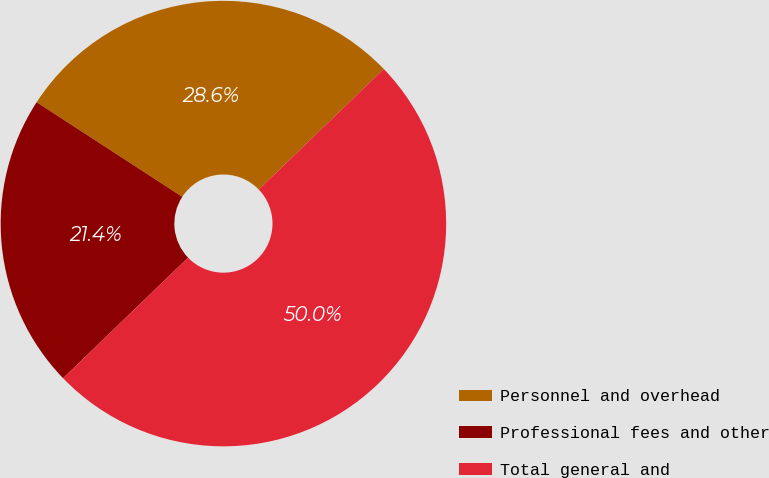Convert chart to OTSL. <chart><loc_0><loc_0><loc_500><loc_500><pie_chart><fcel>Personnel and overhead<fcel>Professional fees and other<fcel>Total general and<nl><fcel>28.62%<fcel>21.38%<fcel>50.0%<nl></chart> 